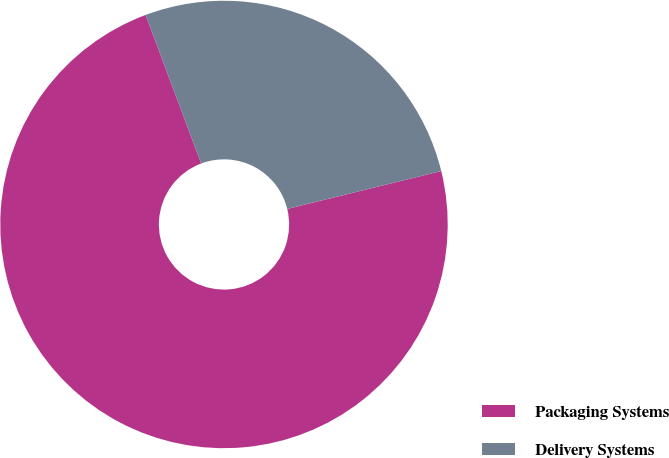Convert chart to OTSL. <chart><loc_0><loc_0><loc_500><loc_500><pie_chart><fcel>Packaging Systems<fcel>Delivery Systems<nl><fcel>73.14%<fcel>26.86%<nl></chart> 